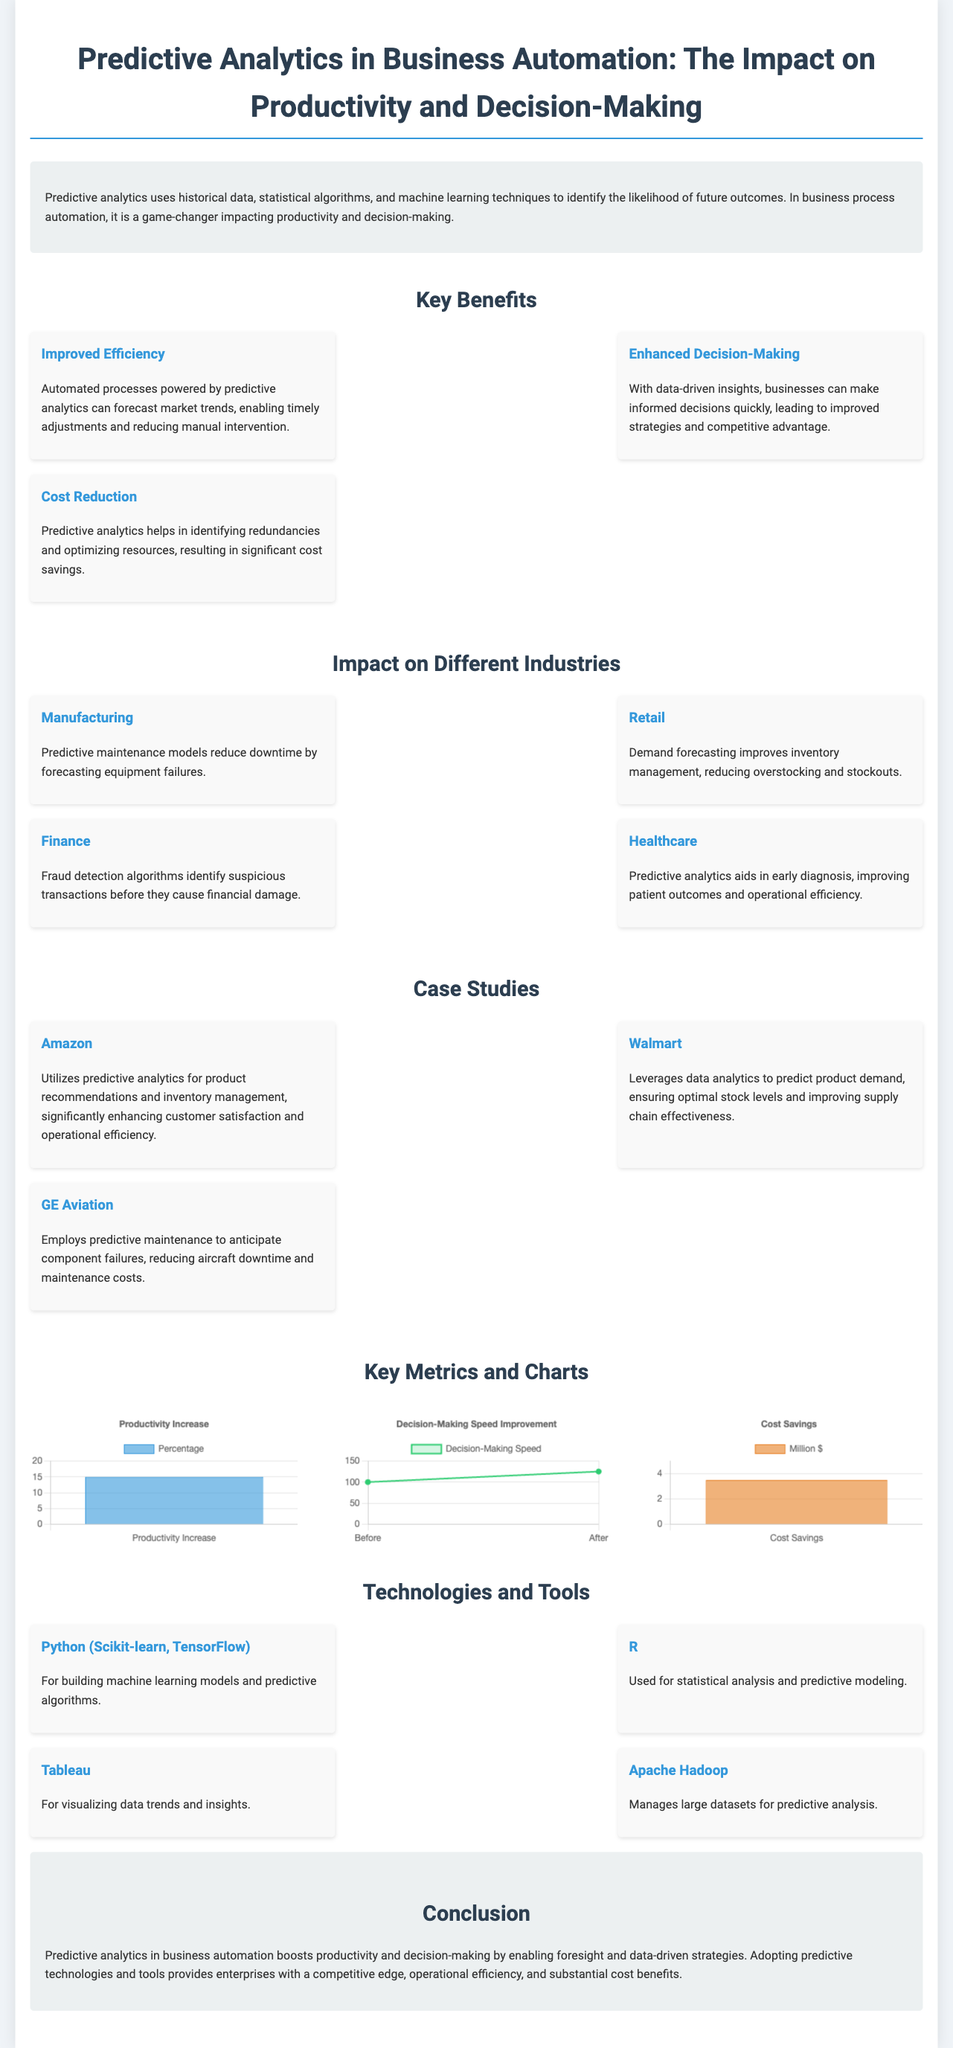what is the productivity increase percentage? The document states that the productivity increase is represented as a percentage in the chart, which is 15.
Answer: 15 what are the two improvements shown in the decision-making speed chart? The chart displays data for 'Before' and 'After' the implementation of predictive analytics, with corresponding values.
Answer: 100, 125 how much cost savings is represented in the chart? The chart indicates the cost savings in millions of dollars, which is shown as 3.5.
Answer: 3.5 million dollars which industry uses predictive analytics for fraud detection? The document mentions that the finance industry utilizes predictive analytics.
Answer: Finance what is one key benefit of predictive analytics related to decision-making? The document highlights that enhanced decision-making is a key benefit, specifically about making informed decisions quickly.
Answer: Enhanced decision-making how does predictive analytics impact manufacturing? The document states that it reduces downtime by forecasting equipment failures in manufacturing.
Answer: Reduces downtime which company uses predictive analytics for product recommendations? The case study section mentions that Amazon uses predictive analytics for this purpose.
Answer: Amazon what tools are mentioned for building machine learning models? The document lists Python, Scikit-learn, and TensorFlow as tools for building models.
Answer: Python, Scikit-learn, TensorFlow what is the maximum value on the y-axis of the cost savings chart? The document specifies that the maximum value on the y-axis of the cost savings chart is 5.
Answer: 5 